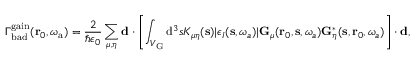<formula> <loc_0><loc_0><loc_500><loc_500>\Gamma _ { b a d } ^ { g a i n } ( r _ { 0 } , \omega _ { a } ) = \frac { 2 } { \hbar { \epsilon } _ { 0 } } \sum _ { \mu , \eta } d \cdot \left [ \int _ { V _ { G } } { \mathrm d } ^ { 3 } s K _ { \mu \eta } ( s ) | \epsilon _ { I } ( s , \omega _ { a } ) | G _ { \mu } ( r _ { 0 } , s , \omega _ { a } ) G _ { \eta } ^ { * } ( s , r _ { 0 } , \omega _ { a } ) \right ] \cdot d ,</formula> 